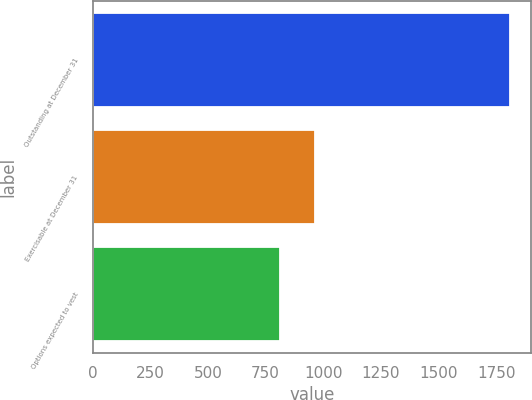Convert chart. <chart><loc_0><loc_0><loc_500><loc_500><bar_chart><fcel>Outstanding at December 31<fcel>Exercisable at December 31<fcel>Options expected to vest<nl><fcel>1810<fcel>964<fcel>814<nl></chart> 